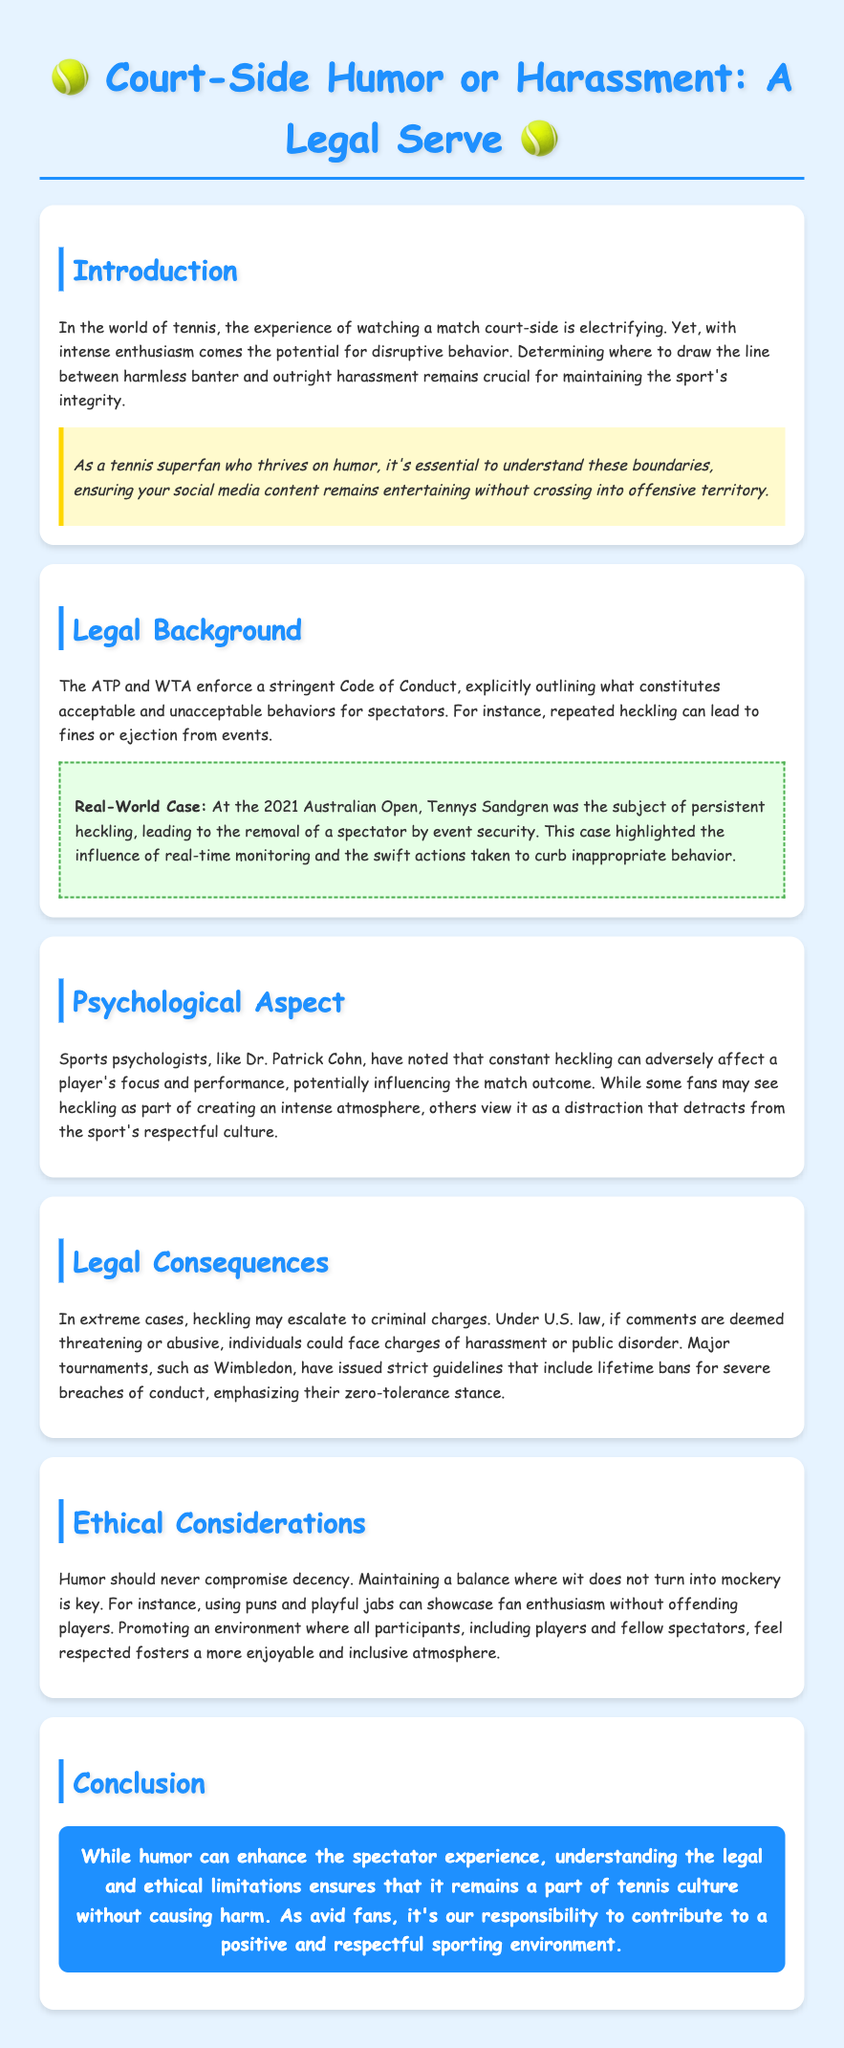what is the title of the document? The title is stated at the top of the document as "Court-Side Humor or Harassment: A Legal Serve."
Answer: Court-Side Humor or Harassment: A Legal Serve who was the subject of persistent heckling at the 2021 Australian Open? The document specifies that Tennys Sandgren was the subject of persistent heckling.
Answer: Tennys Sandgren what can repeated heckling lead to according to the ATP and WTA Code of Conduct? The document mentions that repeated heckling can lead to fines or ejection from events.
Answer: fines or ejection who noted that constant heckling can adversely affect a player's focus? The document states that sports psychologists like Dr. Patrick Cohn have noted this effect.
Answer: Dr. Patrick Cohn what kind of charges can extreme cases of heckling escalate to? The document indicates that heckling may escalate to criminal charges if comments are threatening or abusive.
Answer: criminal charges how do major tournaments like Wimbledon respond to severe breaches of conduct? The document mentions that major tournaments like Wimbledon have issued lifetime bans for severe breaches.
Answer: lifetime bans what does the document suggest using as playful jabs to avoid mockery? The document suggests using puns and playful jabs to maintain a balance.
Answer: puns and playful jabs what is the main responsibility of fans according to the conclusion? The conclusion emphasizes that it's the fans' responsibility to contribute to a positive environment.
Answer: contribute to a positive environment 